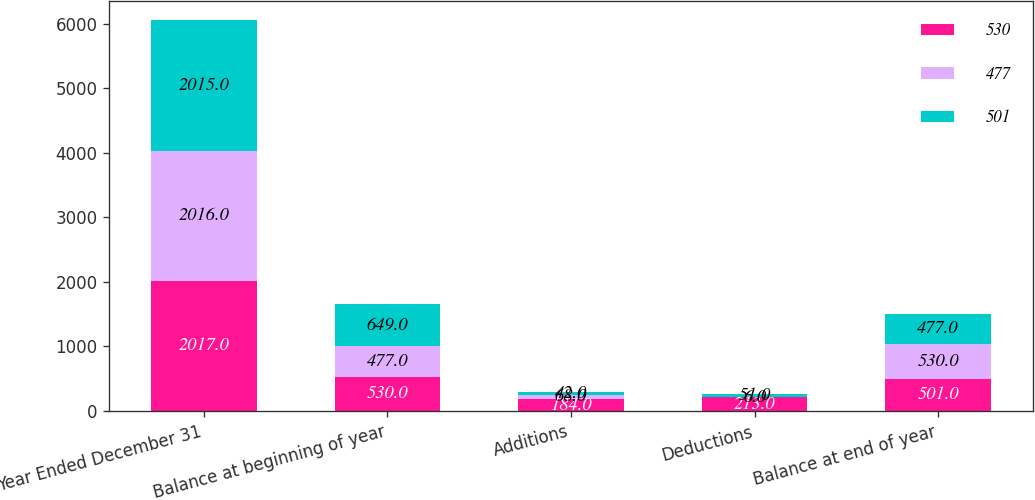Convert chart. <chart><loc_0><loc_0><loc_500><loc_500><stacked_bar_chart><ecel><fcel>Year Ended December 31<fcel>Balance at beginning of year<fcel>Additions<fcel>Deductions<fcel>Balance at end of year<nl><fcel>530<fcel>2017<fcel>530<fcel>184<fcel>213<fcel>501<nl><fcel>477<fcel>2016<fcel>477<fcel>68<fcel>6<fcel>530<nl><fcel>501<fcel>2015<fcel>649<fcel>42<fcel>51<fcel>477<nl></chart> 